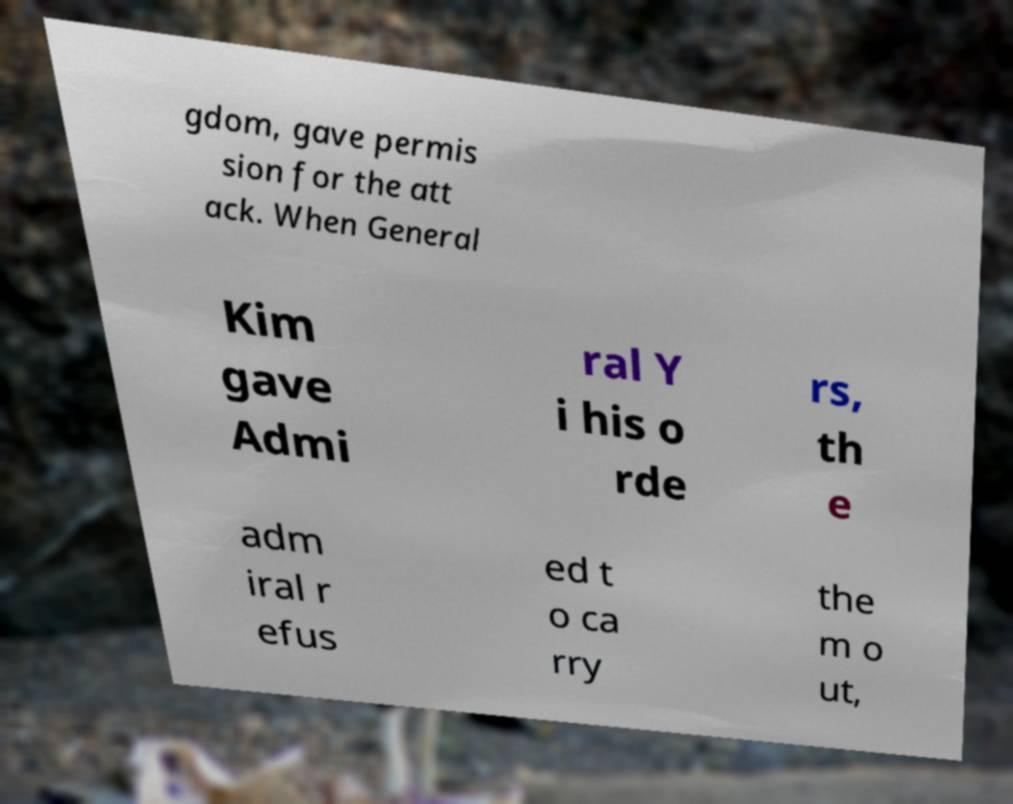I need the written content from this picture converted into text. Can you do that? gdom, gave permis sion for the att ack. When General Kim gave Admi ral Y i his o rde rs, th e adm iral r efus ed t o ca rry the m o ut, 